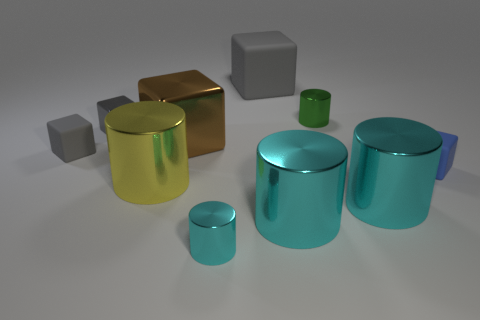What can you infer about the lighting source in the image? Based on the shadows cast by the objects and the bright areas on their surfaces, the lighting source in the image appears to come from the upper right-hand side. It is likely a single, strong light source given the sharpness of the shadows and the focused highlights on the objects. 